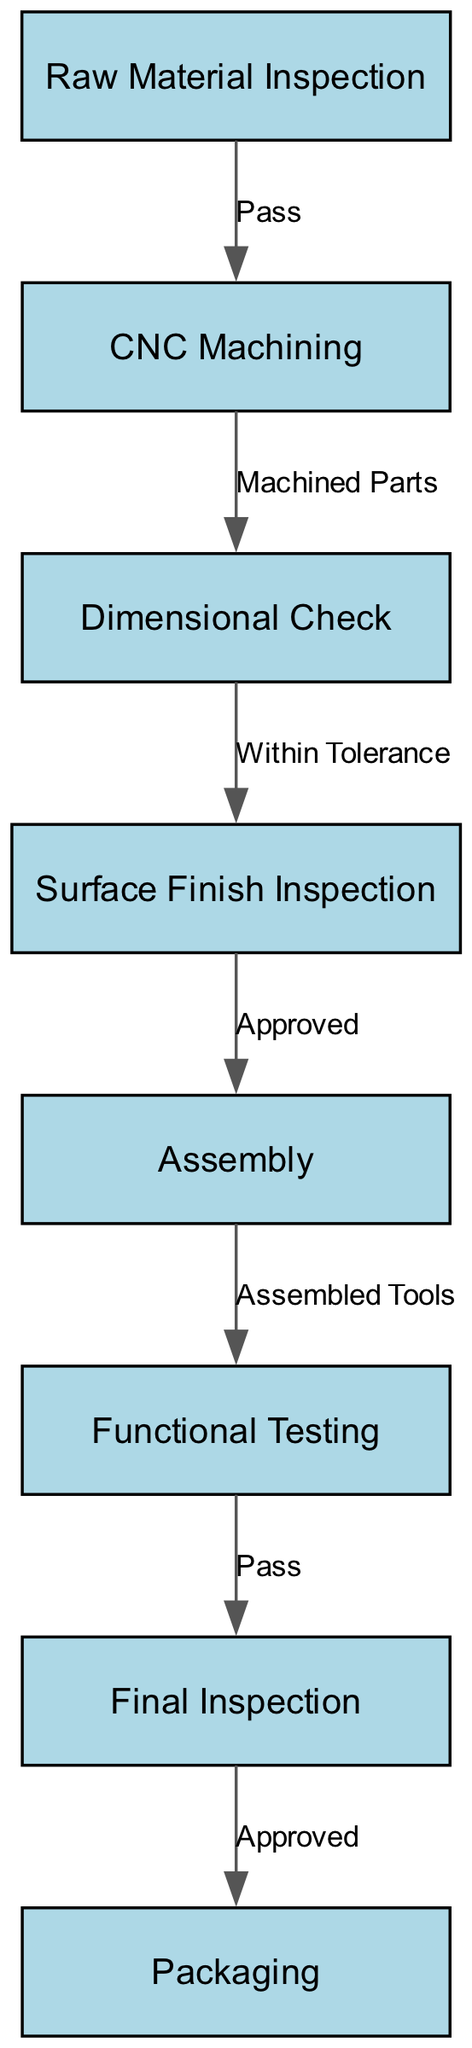What is the first step in the quality control process? The first step in the quality control process is "Raw Material Inspection," which is the starting node in the flowchart.
Answer: Raw Material Inspection How many nodes are in the diagram? By counting each labeled process from the nodes section provided, there are a total of eight distinct nodes in the diagram.
Answer: 8 What is the label of the last node? The last node in the flowchart is "Packaging," which is the final step in the quality control process as depicted in the diagram.
Answer: Packaging What is the relationship between CNC Machining and Dimensional Check? The relationship is represented by the edge labeled "Machined Parts" indicating that once the CNC Machining is completed, the product moves to the Dimensional Check step.
Answer: Machined Parts What must happen after Functional Testing before proceeding to the next step? After Functional Testing, the product must "Pass" in order to move on to the Final Inspection, fulfilling the requirement to proceed in the process.
Answer: Pass What is the consequence of failing the Dimensional Check? The flowchart doesn't explicitly show negative outcomes, but failing a check typically means not proceeding to the next steps, which indicates the process would essentially halt or require re-inspection.
Answer: Not specified What step follows after the Surface Finish Inspection? Following the Surface Finish Inspection, the next step is Assembly, where the approved components are put together.
Answer: Assembly If a tool fails the Final Inspection, what is the implication for Packaging? If the Final Inspection is failed, it would imply that the tool cannot be packaged since only approved items proceed to this final step of the manufacturing process.
Answer: Cannot package 